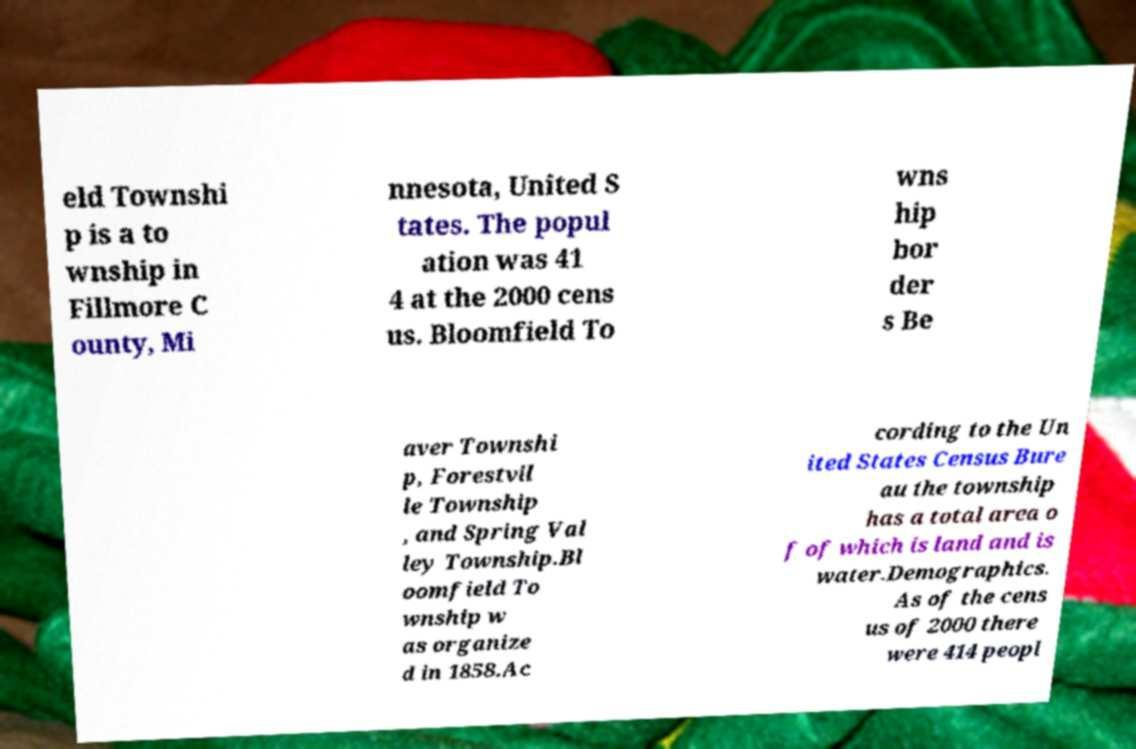There's text embedded in this image that I need extracted. Can you transcribe it verbatim? eld Townshi p is a to wnship in Fillmore C ounty, Mi nnesota, United S tates. The popul ation was 41 4 at the 2000 cens us. Bloomfield To wns hip bor der s Be aver Townshi p, Forestvil le Township , and Spring Val ley Township.Bl oomfield To wnship w as organize d in 1858.Ac cording to the Un ited States Census Bure au the township has a total area o f of which is land and is water.Demographics. As of the cens us of 2000 there were 414 peopl 